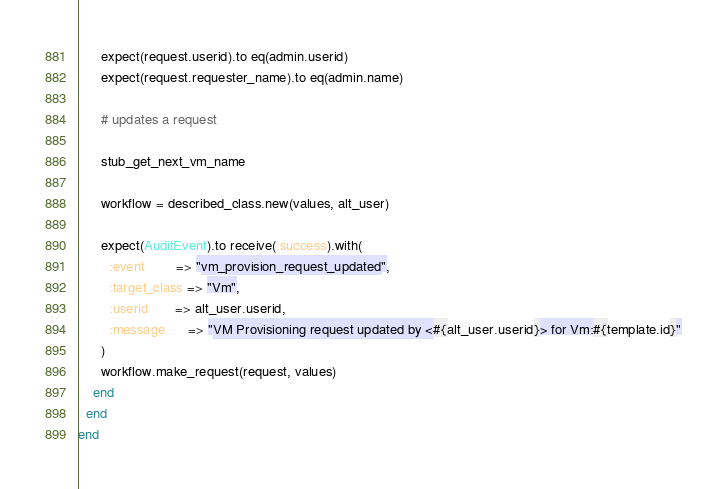Convert code to text. <code><loc_0><loc_0><loc_500><loc_500><_Ruby_>      expect(request.userid).to eq(admin.userid)
      expect(request.requester_name).to eq(admin.name)

      # updates a request

      stub_get_next_vm_name

      workflow = described_class.new(values, alt_user)

      expect(AuditEvent).to receive(:success).with(
        :event        => "vm_provision_request_updated",
        :target_class => "Vm",
        :userid       => alt_user.userid,
        :message      => "VM Provisioning request updated by <#{alt_user.userid}> for Vm:#{template.id}"
      )
      workflow.make_request(request, values)
    end
  end
end
</code> 